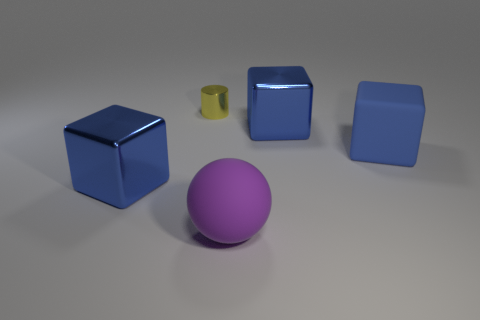How many other objects are there of the same size as the yellow thing?
Your answer should be compact. 0. Is the big object that is on the left side of the big purple rubber thing made of the same material as the yellow cylinder?
Provide a short and direct response. Yes. What number of other objects are the same color as the big rubber block?
Ensure brevity in your answer.  2. What number of other objects are the same shape as the purple rubber thing?
Your answer should be very brief. 0. Does the blue metallic thing that is behind the blue rubber cube have the same shape as the metal thing that is in front of the blue matte object?
Your answer should be very brief. Yes. Is the number of large purple objects that are in front of the small thing the same as the number of metallic cubes left of the large purple matte ball?
Offer a terse response. Yes. There is a big matte thing that is on the right side of the large thing in front of the metallic block that is on the left side of the big purple ball; what is its shape?
Provide a succinct answer. Cube. Do the big blue cube to the left of the matte sphere and the yellow cylinder that is behind the large purple thing have the same material?
Keep it short and to the point. Yes. There is a big metallic thing that is in front of the big blue matte cube; what is its shape?
Offer a terse response. Cube. Is the number of cylinders less than the number of metal objects?
Ensure brevity in your answer.  Yes. 